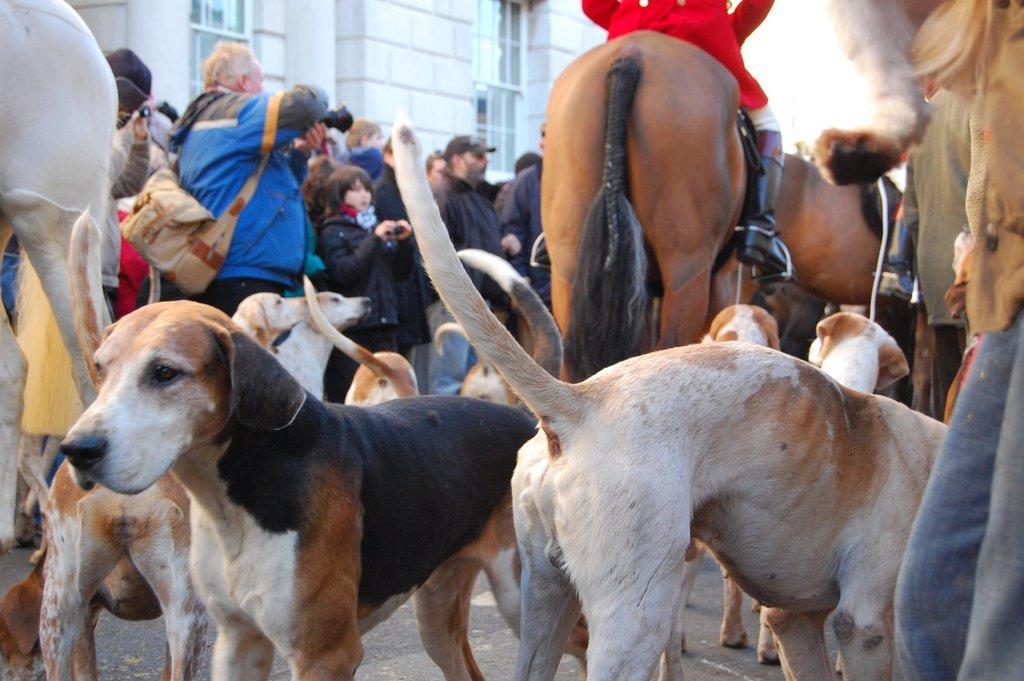Describe this image in one or two sentences. In this picture there are few dogs,horses and people standing and there is a building in the background. 